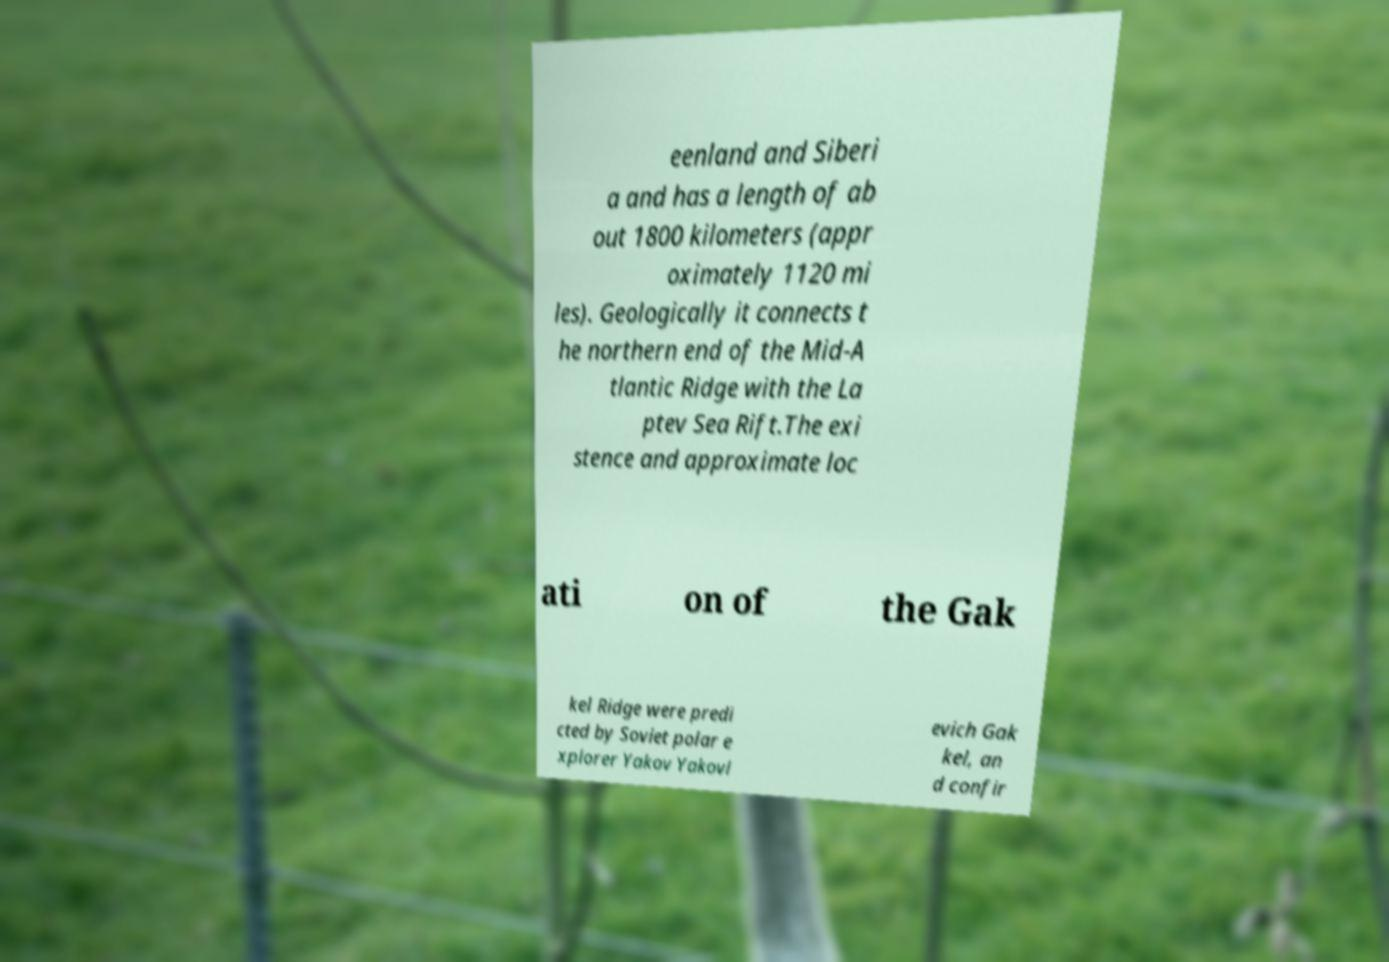What messages or text are displayed in this image? I need them in a readable, typed format. eenland and Siberi a and has a length of ab out 1800 kilometers (appr oximately 1120 mi les). Geologically it connects t he northern end of the Mid-A tlantic Ridge with the La ptev Sea Rift.The exi stence and approximate loc ati on of the Gak kel Ridge were predi cted by Soviet polar e xplorer Yakov Yakovl evich Gak kel, an d confir 